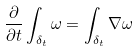<formula> <loc_0><loc_0><loc_500><loc_500>\frac { \partial } { \partial t } \int _ { \delta _ { t } } \omega = \int _ { \delta _ { t } } \nabla \omega</formula> 